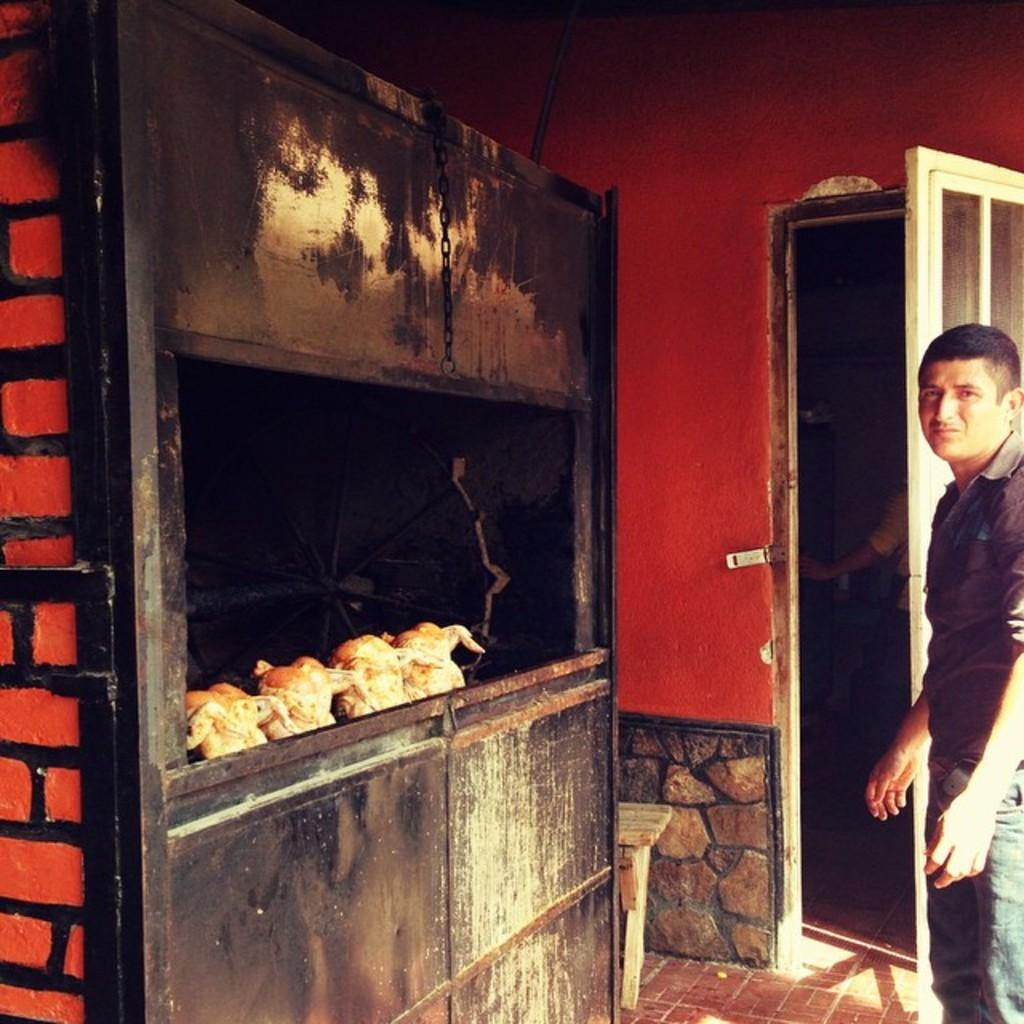Who or what is on the right side of the image? There is a person on the right side of the image. What can be seen in the image besides the person? There is a door and a box on the left side of the image. What is inside the box? There are chickens inside the box. What is visible in the background of the image? There is a wall in the background of the image. What time of day is it in the image, based on the hour? The provided facts do not mention the time of day or any hour, so it cannot be determined from the image. 